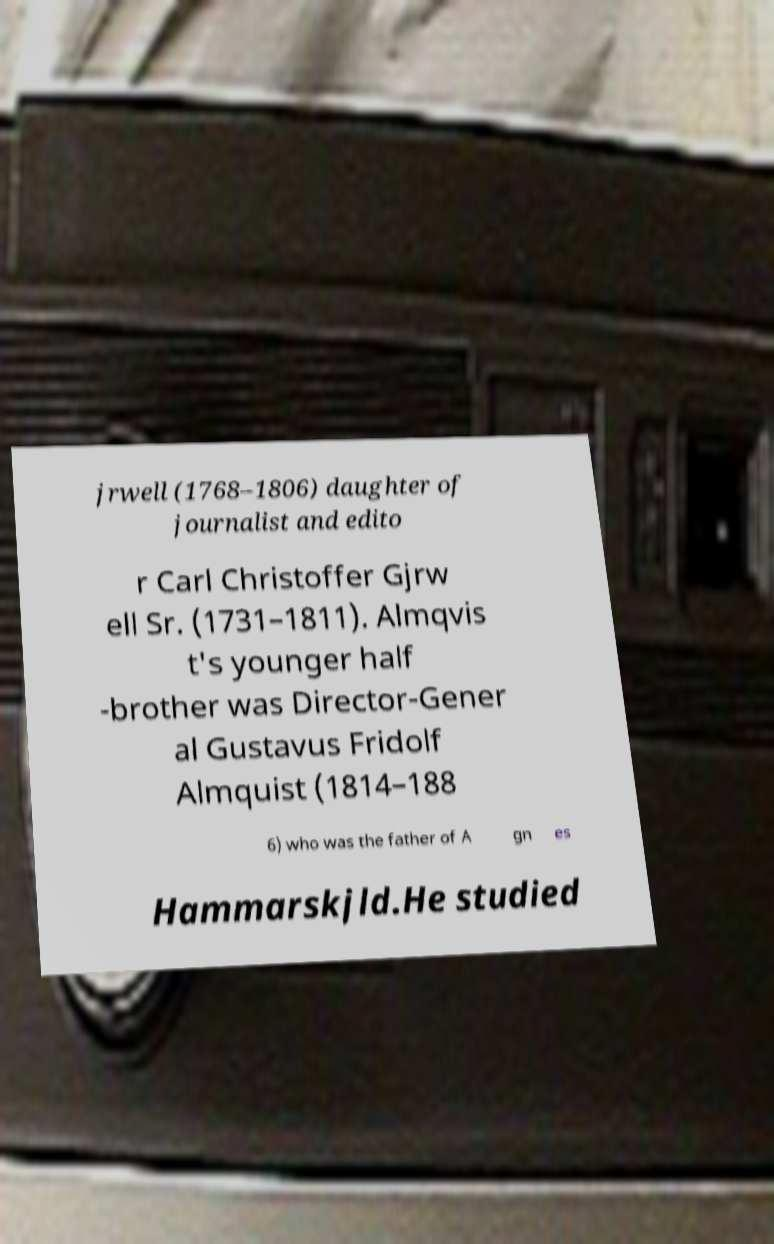For documentation purposes, I need the text within this image transcribed. Could you provide that? jrwell (1768–1806) daughter of journalist and edito r Carl Christoffer Gjrw ell Sr. (1731–1811). Almqvis t's younger half -brother was Director-Gener al Gustavus Fridolf Almquist (1814–188 6) who was the father of A gn es Hammarskjld.He studied 